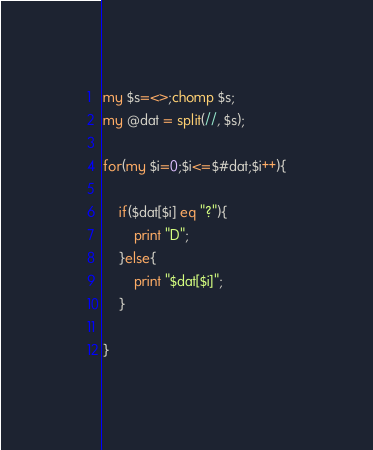<code> <loc_0><loc_0><loc_500><loc_500><_Perl_>my $s=<>;chomp $s;
my @dat = split(//, $s);

for(my $i=0;$i<=$#dat;$i++){
    
    if($dat[$i] eq "?"){
        print "D";
    }else{
        print "$dat[$i]";
    }
    
}</code> 